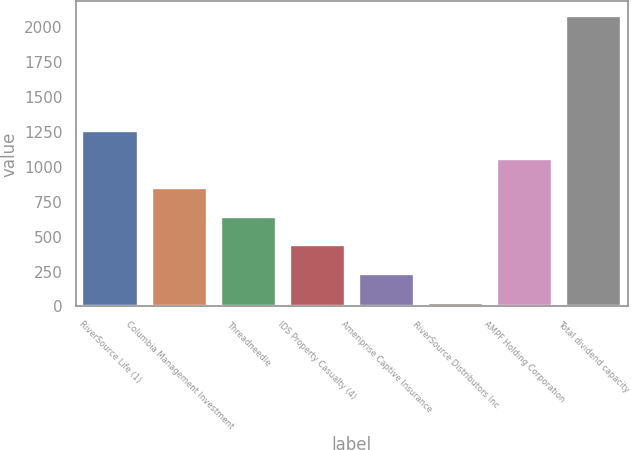Convert chart to OTSL. <chart><loc_0><loc_0><loc_500><loc_500><bar_chart><fcel>RiverSource Life (1)<fcel>Columbia Management Investment<fcel>Threadneedle<fcel>IDS Property Casualty (4)<fcel>Ameriprise Captive Insurance<fcel>RiverSource Distributors Inc<fcel>AMPF Holding Corporation<fcel>Total dividend capacity<nl><fcel>1258.4<fcel>847.6<fcel>642.2<fcel>436.8<fcel>231.4<fcel>26<fcel>1053<fcel>2080<nl></chart> 